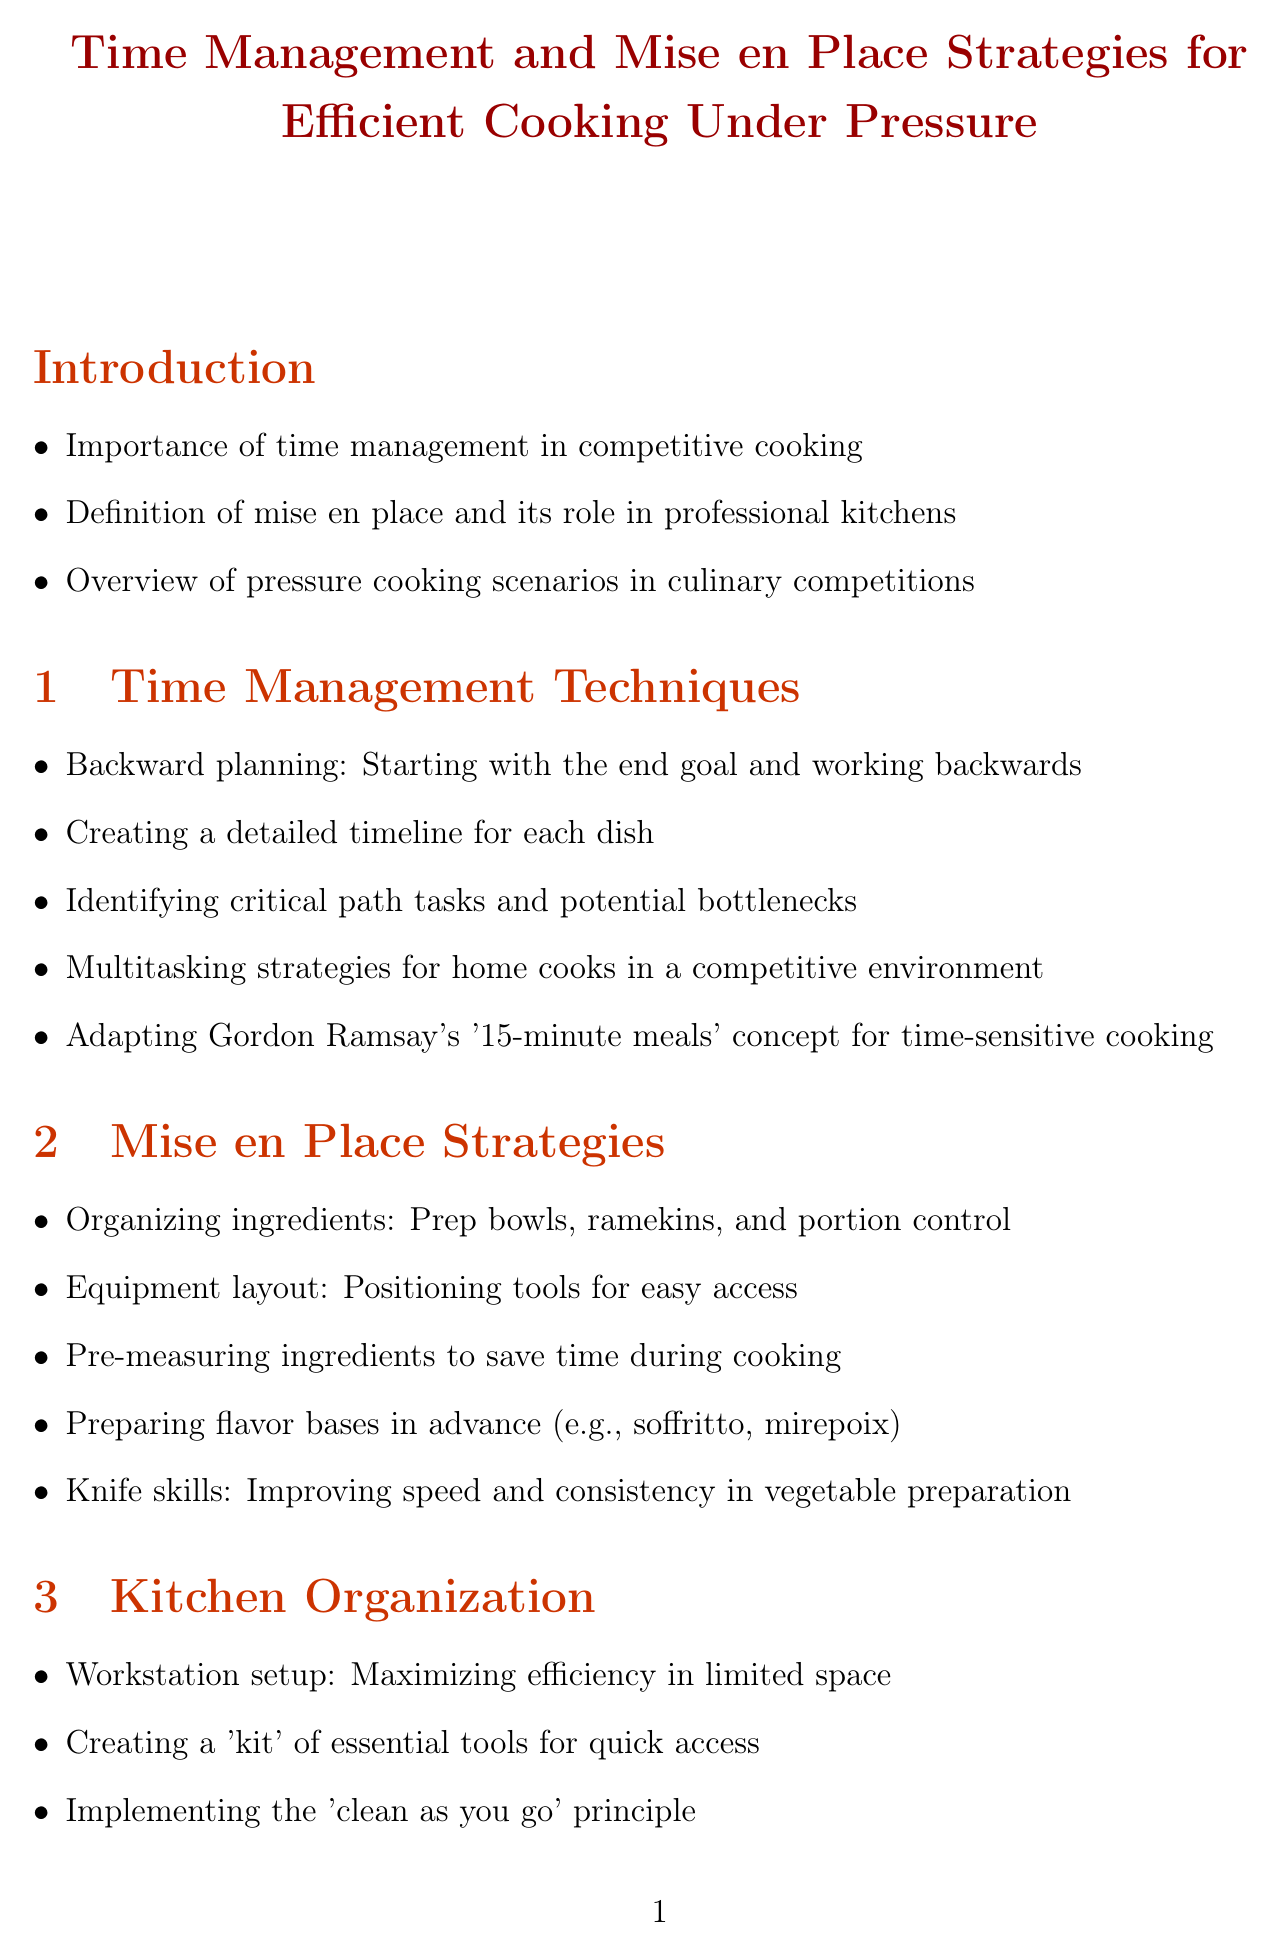What is the title of the document? The title is explicitly stated at the beginning of the document.
Answer: Time Management and Mise en Place Strategies for Efficient Cooking Under Pressure What technique is used for backward planning? The document lists "Backward planning" as a technique under time management strategies.
Answer: Starting with the end goal and working backwards What is the primary focus of mise en place strategies? The section outlines key practices for organizing ingredients and tools in the kitchen.
Answer: Organizing ingredients Which chef's meals concept is mentioned for time-sensitive cooking? The document refers to a popular cooking concept from a well-known chef.
Answer: Gordon Ramsay's '15-minute meals' What should you implement to maintain workstation efficiency? The document emphasizes a crucial principle for kitchen organization.
Answer: Clean as you go What type of exercises are suggested for improving speed? The document includes practical exercises designed for competitive cooking practice.
Answer: 30-minute meal challenges What should be prepared in advance according to recipe optimization? This refers to components that can save time in the cooking process.
Answer: Identifying components that can be prepared in advance Which technique helps in staying calm during competitions? This is a mental preparation method mentioned in the document.
Answer: Developing a personal mantra How many practice exercises and drills are listed? The document provides a specific count of different exercises for practice.
Answer: Five 